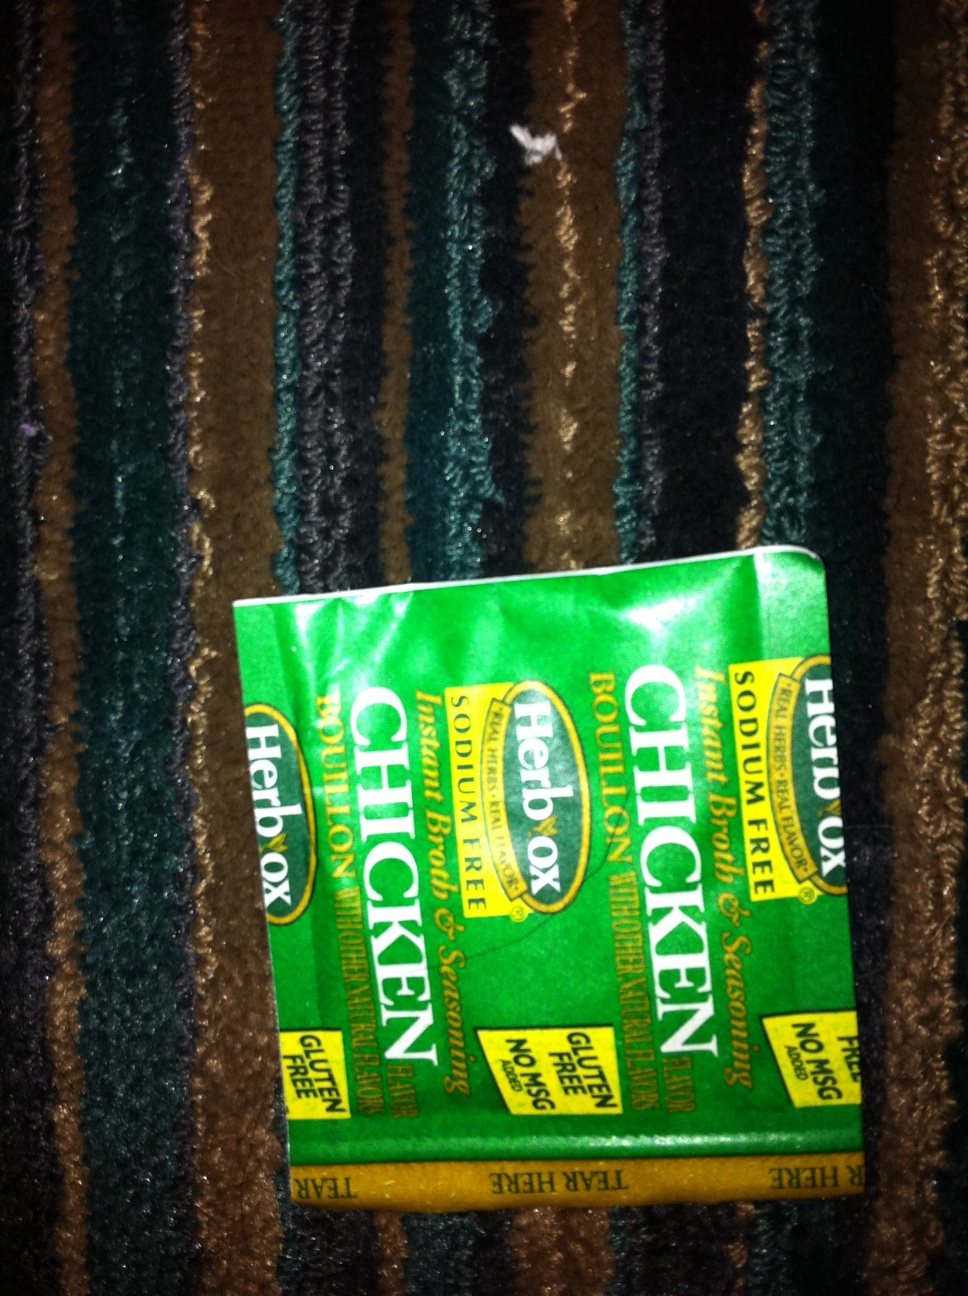Can you suggest a creative recipe using this bouillon? Sure, here’s a delicious Chicken Bouillon Rice Pilaf recipe:

1. In a medium-sized pot, dissolve one packet of Herbox Chicken Bouillon in one and a half cups of boiling water.
2. Add one cup of jasmine rice, one tablespoon of butter, and one minced garlic clove.
3. Bring to a boil, then cover and reduce the heat to low. Simmer for 15-20 minutes or until the rice is tender and the water is absorbed.
4. Fluff the rice with a fork, then add a handful of chopped parsley and some lemon zest. Mix well.
5. Serve as a side dish with grilled chicken or fish. 